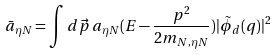<formula> <loc_0><loc_0><loc_500><loc_500>\bar { a } _ { \eta N } = \int d \vec { p } \, a _ { \eta N } ( E - \frac { p ^ { 2 } } { 2 m _ { N , \eta N } } ) | \tilde { \phi } _ { d } ( q ) | ^ { 2 }</formula> 